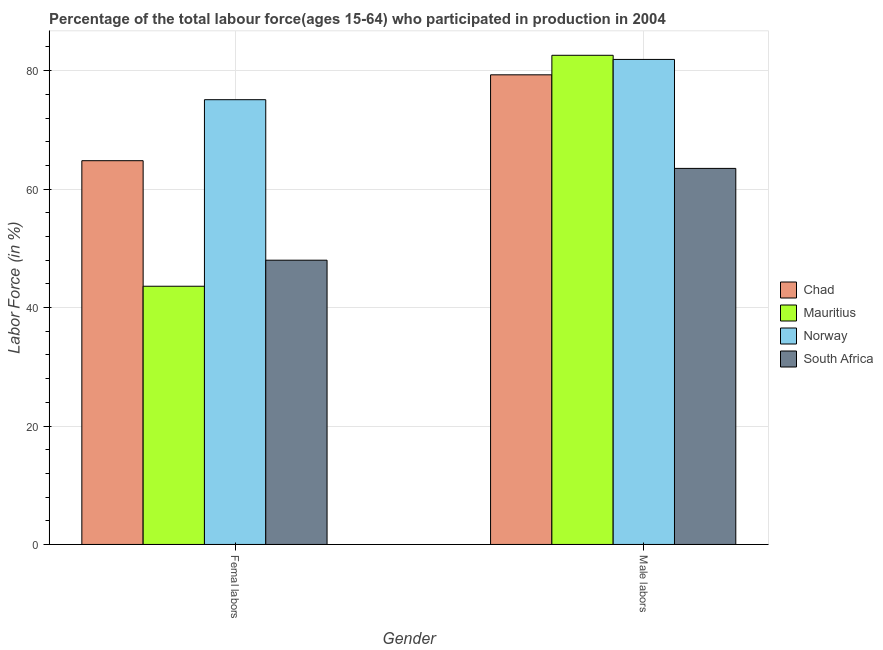How many groups of bars are there?
Keep it short and to the point. 2. How many bars are there on the 2nd tick from the right?
Offer a terse response. 4. What is the label of the 2nd group of bars from the left?
Keep it short and to the point. Male labors. What is the percentage of female labor force in Norway?
Your answer should be compact. 75.1. Across all countries, what is the maximum percentage of female labor force?
Your response must be concise. 75.1. Across all countries, what is the minimum percentage of male labour force?
Your answer should be very brief. 63.5. In which country was the percentage of female labor force maximum?
Make the answer very short. Norway. In which country was the percentage of male labour force minimum?
Your answer should be very brief. South Africa. What is the total percentage of female labor force in the graph?
Your answer should be compact. 231.5. What is the difference between the percentage of male labour force in Norway and that in Mauritius?
Offer a terse response. -0.7. What is the difference between the percentage of female labor force in Chad and the percentage of male labour force in South Africa?
Your answer should be very brief. 1.3. What is the average percentage of male labour force per country?
Offer a terse response. 76.83. What is the difference between the percentage of male labour force and percentage of female labor force in South Africa?
Offer a terse response. 15.5. In how many countries, is the percentage of male labour force greater than 8 %?
Your answer should be very brief. 4. What is the ratio of the percentage of male labour force in South Africa to that in Norway?
Offer a very short reply. 0.78. Is the percentage of male labour force in Norway less than that in Chad?
Provide a short and direct response. No. What does the 1st bar from the left in Male labors represents?
Provide a succinct answer. Chad. How many bars are there?
Offer a terse response. 8. How many countries are there in the graph?
Your response must be concise. 4. What is the difference between two consecutive major ticks on the Y-axis?
Provide a succinct answer. 20. Are the values on the major ticks of Y-axis written in scientific E-notation?
Ensure brevity in your answer.  No. Does the graph contain any zero values?
Your answer should be very brief. No. Does the graph contain grids?
Offer a very short reply. Yes. How are the legend labels stacked?
Keep it short and to the point. Vertical. What is the title of the graph?
Offer a terse response. Percentage of the total labour force(ages 15-64) who participated in production in 2004. What is the label or title of the X-axis?
Provide a succinct answer. Gender. What is the label or title of the Y-axis?
Make the answer very short. Labor Force (in %). What is the Labor Force (in %) of Chad in Femal labors?
Provide a short and direct response. 64.8. What is the Labor Force (in %) in Mauritius in Femal labors?
Offer a terse response. 43.6. What is the Labor Force (in %) in Norway in Femal labors?
Your response must be concise. 75.1. What is the Labor Force (in %) in South Africa in Femal labors?
Your answer should be compact. 48. What is the Labor Force (in %) of Chad in Male labors?
Your response must be concise. 79.3. What is the Labor Force (in %) of Mauritius in Male labors?
Keep it short and to the point. 82.6. What is the Labor Force (in %) in Norway in Male labors?
Offer a terse response. 81.9. What is the Labor Force (in %) of South Africa in Male labors?
Offer a very short reply. 63.5. Across all Gender, what is the maximum Labor Force (in %) of Chad?
Your answer should be compact. 79.3. Across all Gender, what is the maximum Labor Force (in %) in Mauritius?
Give a very brief answer. 82.6. Across all Gender, what is the maximum Labor Force (in %) of Norway?
Your response must be concise. 81.9. Across all Gender, what is the maximum Labor Force (in %) of South Africa?
Your answer should be compact. 63.5. Across all Gender, what is the minimum Labor Force (in %) of Chad?
Give a very brief answer. 64.8. Across all Gender, what is the minimum Labor Force (in %) in Mauritius?
Offer a very short reply. 43.6. Across all Gender, what is the minimum Labor Force (in %) of Norway?
Keep it short and to the point. 75.1. Across all Gender, what is the minimum Labor Force (in %) of South Africa?
Your response must be concise. 48. What is the total Labor Force (in %) in Chad in the graph?
Keep it short and to the point. 144.1. What is the total Labor Force (in %) in Mauritius in the graph?
Keep it short and to the point. 126.2. What is the total Labor Force (in %) of Norway in the graph?
Offer a very short reply. 157. What is the total Labor Force (in %) of South Africa in the graph?
Offer a terse response. 111.5. What is the difference between the Labor Force (in %) of Chad in Femal labors and that in Male labors?
Offer a very short reply. -14.5. What is the difference between the Labor Force (in %) in Mauritius in Femal labors and that in Male labors?
Provide a short and direct response. -39. What is the difference between the Labor Force (in %) of South Africa in Femal labors and that in Male labors?
Your answer should be compact. -15.5. What is the difference between the Labor Force (in %) of Chad in Femal labors and the Labor Force (in %) of Mauritius in Male labors?
Your response must be concise. -17.8. What is the difference between the Labor Force (in %) of Chad in Femal labors and the Labor Force (in %) of Norway in Male labors?
Provide a succinct answer. -17.1. What is the difference between the Labor Force (in %) in Chad in Femal labors and the Labor Force (in %) in South Africa in Male labors?
Keep it short and to the point. 1.3. What is the difference between the Labor Force (in %) in Mauritius in Femal labors and the Labor Force (in %) in Norway in Male labors?
Your response must be concise. -38.3. What is the difference between the Labor Force (in %) of Mauritius in Femal labors and the Labor Force (in %) of South Africa in Male labors?
Make the answer very short. -19.9. What is the difference between the Labor Force (in %) in Norway in Femal labors and the Labor Force (in %) in South Africa in Male labors?
Ensure brevity in your answer.  11.6. What is the average Labor Force (in %) in Chad per Gender?
Give a very brief answer. 72.05. What is the average Labor Force (in %) of Mauritius per Gender?
Offer a terse response. 63.1. What is the average Labor Force (in %) in Norway per Gender?
Your response must be concise. 78.5. What is the average Labor Force (in %) of South Africa per Gender?
Make the answer very short. 55.75. What is the difference between the Labor Force (in %) in Chad and Labor Force (in %) in Mauritius in Femal labors?
Provide a succinct answer. 21.2. What is the difference between the Labor Force (in %) in Mauritius and Labor Force (in %) in Norway in Femal labors?
Your answer should be very brief. -31.5. What is the difference between the Labor Force (in %) of Norway and Labor Force (in %) of South Africa in Femal labors?
Provide a short and direct response. 27.1. What is the difference between the Labor Force (in %) in Chad and Labor Force (in %) in Mauritius in Male labors?
Ensure brevity in your answer.  -3.3. What is the difference between the Labor Force (in %) of Chad and Labor Force (in %) of Norway in Male labors?
Your answer should be compact. -2.6. What is the difference between the Labor Force (in %) in Mauritius and Labor Force (in %) in Norway in Male labors?
Your response must be concise. 0.7. What is the difference between the Labor Force (in %) in Mauritius and Labor Force (in %) in South Africa in Male labors?
Give a very brief answer. 19.1. What is the ratio of the Labor Force (in %) in Chad in Femal labors to that in Male labors?
Provide a short and direct response. 0.82. What is the ratio of the Labor Force (in %) of Mauritius in Femal labors to that in Male labors?
Your response must be concise. 0.53. What is the ratio of the Labor Force (in %) in Norway in Femal labors to that in Male labors?
Your answer should be very brief. 0.92. What is the ratio of the Labor Force (in %) of South Africa in Femal labors to that in Male labors?
Ensure brevity in your answer.  0.76. What is the difference between the highest and the second highest Labor Force (in %) of Chad?
Keep it short and to the point. 14.5. What is the difference between the highest and the second highest Labor Force (in %) of Mauritius?
Offer a terse response. 39. What is the difference between the highest and the second highest Labor Force (in %) in Norway?
Provide a short and direct response. 6.8. What is the difference between the highest and the lowest Labor Force (in %) in Mauritius?
Offer a very short reply. 39. What is the difference between the highest and the lowest Labor Force (in %) of Norway?
Provide a short and direct response. 6.8. 